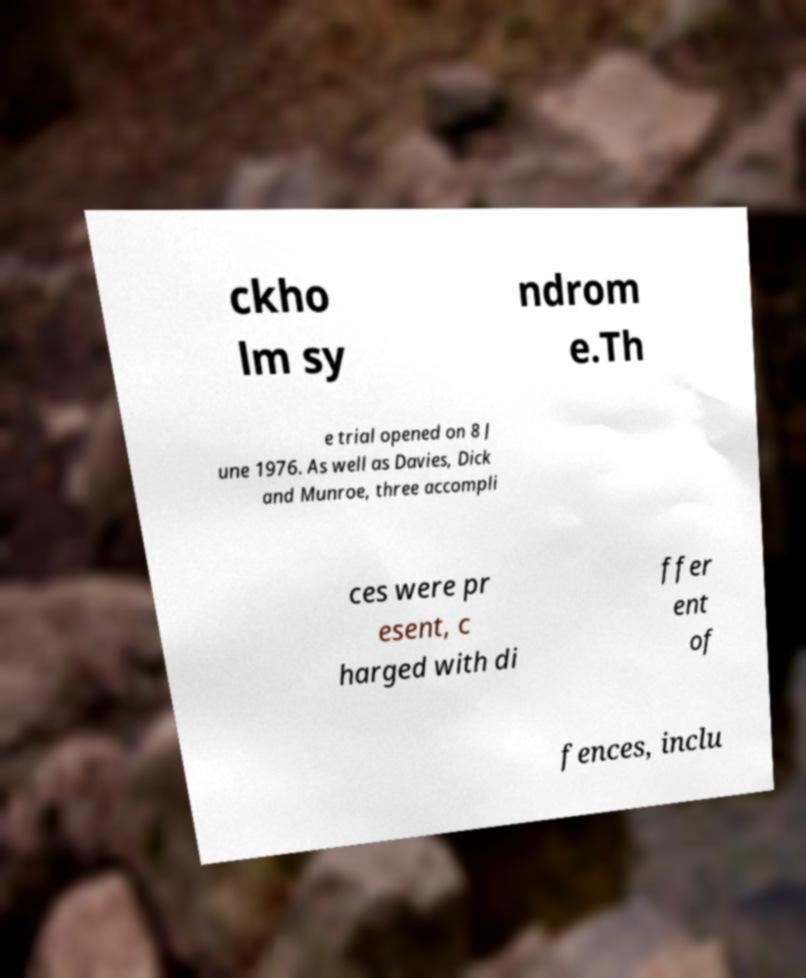Please identify and transcribe the text found in this image. ckho lm sy ndrom e.Th e trial opened on 8 J une 1976. As well as Davies, Dick and Munroe, three accompli ces were pr esent, c harged with di ffer ent of fences, inclu 